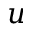Convert formula to latex. <formula><loc_0><loc_0><loc_500><loc_500>u</formula> 